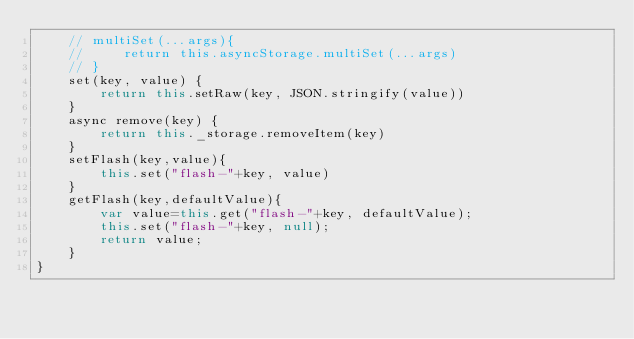<code> <loc_0><loc_0><loc_500><loc_500><_JavaScript_>    // multiSet(...args){
    //     return this.asyncStorage.multiSet(...args)
    // }
    set(key, value) {
        return this.setRaw(key, JSON.stringify(value))
    }
    async remove(key) {
        return this._storage.removeItem(key)
    }
    setFlash(key,value){
        this.set("flash-"+key, value)
    }
    getFlash(key,defaultValue){
        var value=this.get("flash-"+key, defaultValue);
        this.set("flash-"+key, null);
        return value;
    }
}</code> 